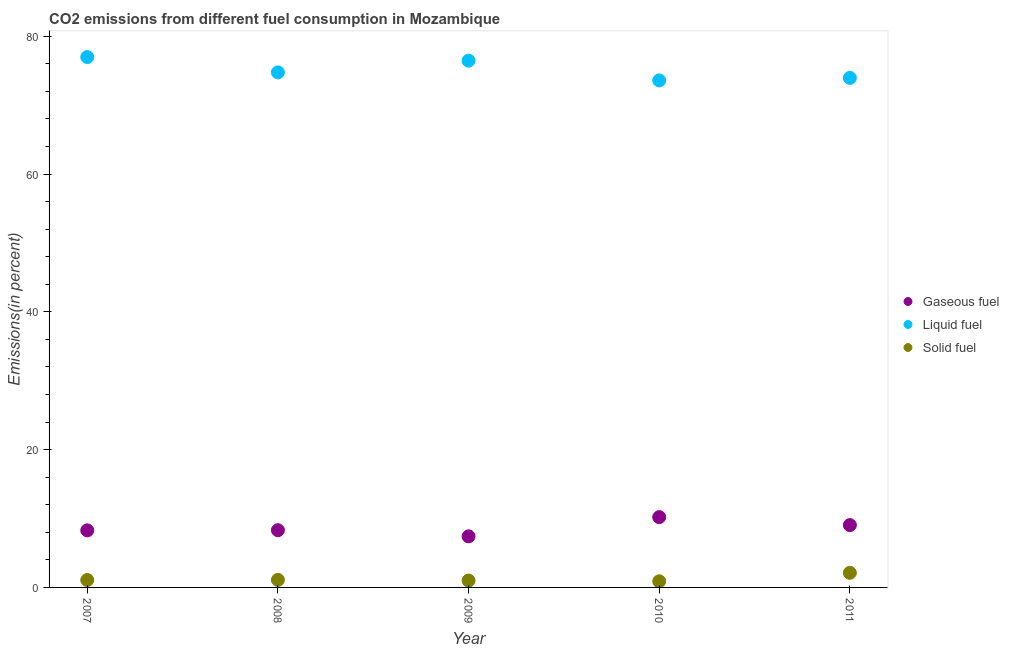What is the percentage of solid fuel emission in 2008?
Provide a short and direct response. 1.1. Across all years, what is the maximum percentage of gaseous fuel emission?
Ensure brevity in your answer.  10.2. Across all years, what is the minimum percentage of gaseous fuel emission?
Your answer should be very brief. 7.42. In which year was the percentage of gaseous fuel emission maximum?
Provide a short and direct response. 2010. What is the total percentage of gaseous fuel emission in the graph?
Provide a short and direct response. 43.26. What is the difference between the percentage of solid fuel emission in 2007 and that in 2011?
Keep it short and to the point. -1.05. What is the difference between the percentage of gaseous fuel emission in 2011 and the percentage of liquid fuel emission in 2009?
Provide a succinct answer. -67.41. What is the average percentage of liquid fuel emission per year?
Make the answer very short. 75.16. In the year 2007, what is the difference between the percentage of liquid fuel emission and percentage of gaseous fuel emission?
Give a very brief answer. 68.71. What is the ratio of the percentage of liquid fuel emission in 2008 to that in 2009?
Keep it short and to the point. 0.98. Is the difference between the percentage of liquid fuel emission in 2008 and 2009 greater than the difference between the percentage of gaseous fuel emission in 2008 and 2009?
Make the answer very short. No. What is the difference between the highest and the second highest percentage of solid fuel emission?
Provide a short and direct response. 1.03. What is the difference between the highest and the lowest percentage of liquid fuel emission?
Offer a terse response. 3.4. Is the sum of the percentage of gaseous fuel emission in 2007 and 2010 greater than the maximum percentage of liquid fuel emission across all years?
Offer a terse response. No. Is it the case that in every year, the sum of the percentage of gaseous fuel emission and percentage of liquid fuel emission is greater than the percentage of solid fuel emission?
Offer a very short reply. Yes. Does the percentage of liquid fuel emission monotonically increase over the years?
Your response must be concise. No. Is the percentage of gaseous fuel emission strictly less than the percentage of solid fuel emission over the years?
Your answer should be compact. No. How many dotlines are there?
Offer a very short reply. 3. How many years are there in the graph?
Your answer should be very brief. 5. Does the graph contain grids?
Provide a succinct answer. No. How are the legend labels stacked?
Your response must be concise. Vertical. What is the title of the graph?
Offer a very short reply. CO2 emissions from different fuel consumption in Mozambique. What is the label or title of the Y-axis?
Make the answer very short. Emissions(in percent). What is the Emissions(in percent) of Gaseous fuel in 2007?
Your answer should be very brief. 8.28. What is the Emissions(in percent) in Liquid fuel in 2007?
Offer a very short reply. 76.99. What is the Emissions(in percent) of Solid fuel in 2007?
Your answer should be compact. 1.07. What is the Emissions(in percent) in Gaseous fuel in 2008?
Make the answer very short. 8.31. What is the Emissions(in percent) of Liquid fuel in 2008?
Give a very brief answer. 74.76. What is the Emissions(in percent) in Solid fuel in 2008?
Offer a very short reply. 1.1. What is the Emissions(in percent) of Gaseous fuel in 2009?
Your response must be concise. 7.42. What is the Emissions(in percent) in Liquid fuel in 2009?
Your answer should be compact. 76.46. What is the Emissions(in percent) in Solid fuel in 2009?
Give a very brief answer. 1. What is the Emissions(in percent) in Gaseous fuel in 2010?
Your answer should be compact. 10.2. What is the Emissions(in percent) in Liquid fuel in 2010?
Offer a very short reply. 73.6. What is the Emissions(in percent) of Solid fuel in 2010?
Your response must be concise. 0.89. What is the Emissions(in percent) in Gaseous fuel in 2011?
Give a very brief answer. 9.05. What is the Emissions(in percent) in Liquid fuel in 2011?
Offer a terse response. 73.97. What is the Emissions(in percent) of Solid fuel in 2011?
Provide a short and direct response. 2.12. Across all years, what is the maximum Emissions(in percent) of Gaseous fuel?
Give a very brief answer. 10.2. Across all years, what is the maximum Emissions(in percent) of Liquid fuel?
Provide a succinct answer. 76.99. Across all years, what is the maximum Emissions(in percent) of Solid fuel?
Provide a succinct answer. 2.12. Across all years, what is the minimum Emissions(in percent) in Gaseous fuel?
Make the answer very short. 7.42. Across all years, what is the minimum Emissions(in percent) of Liquid fuel?
Make the answer very short. 73.6. Across all years, what is the minimum Emissions(in percent) in Solid fuel?
Your response must be concise. 0.89. What is the total Emissions(in percent) in Gaseous fuel in the graph?
Your answer should be very brief. 43.26. What is the total Emissions(in percent) of Liquid fuel in the graph?
Make the answer very short. 375.78. What is the total Emissions(in percent) in Solid fuel in the graph?
Your answer should be very brief. 6.19. What is the difference between the Emissions(in percent) of Gaseous fuel in 2007 and that in 2008?
Your response must be concise. -0.03. What is the difference between the Emissions(in percent) of Liquid fuel in 2007 and that in 2008?
Provide a succinct answer. 2.23. What is the difference between the Emissions(in percent) of Solid fuel in 2007 and that in 2008?
Ensure brevity in your answer.  -0.02. What is the difference between the Emissions(in percent) of Gaseous fuel in 2007 and that in 2009?
Provide a succinct answer. 0.86. What is the difference between the Emissions(in percent) in Liquid fuel in 2007 and that in 2009?
Your answer should be compact. 0.53. What is the difference between the Emissions(in percent) of Solid fuel in 2007 and that in 2009?
Your answer should be compact. 0.07. What is the difference between the Emissions(in percent) in Gaseous fuel in 2007 and that in 2010?
Provide a short and direct response. -1.92. What is the difference between the Emissions(in percent) in Liquid fuel in 2007 and that in 2010?
Ensure brevity in your answer.  3.4. What is the difference between the Emissions(in percent) of Solid fuel in 2007 and that in 2010?
Keep it short and to the point. 0.18. What is the difference between the Emissions(in percent) of Gaseous fuel in 2007 and that in 2011?
Offer a very short reply. -0.77. What is the difference between the Emissions(in percent) of Liquid fuel in 2007 and that in 2011?
Ensure brevity in your answer.  3.03. What is the difference between the Emissions(in percent) of Solid fuel in 2007 and that in 2011?
Give a very brief answer. -1.05. What is the difference between the Emissions(in percent) in Gaseous fuel in 2008 and that in 2009?
Give a very brief answer. 0.89. What is the difference between the Emissions(in percent) in Liquid fuel in 2008 and that in 2009?
Your answer should be very brief. -1.7. What is the difference between the Emissions(in percent) in Solid fuel in 2008 and that in 2009?
Make the answer very short. 0.1. What is the difference between the Emissions(in percent) in Gaseous fuel in 2008 and that in 2010?
Give a very brief answer. -1.9. What is the difference between the Emissions(in percent) of Liquid fuel in 2008 and that in 2010?
Your answer should be very brief. 1.17. What is the difference between the Emissions(in percent) of Solid fuel in 2008 and that in 2010?
Keep it short and to the point. 0.2. What is the difference between the Emissions(in percent) of Gaseous fuel in 2008 and that in 2011?
Provide a short and direct response. -0.74. What is the difference between the Emissions(in percent) in Liquid fuel in 2008 and that in 2011?
Your answer should be compact. 0.8. What is the difference between the Emissions(in percent) of Solid fuel in 2008 and that in 2011?
Your response must be concise. -1.03. What is the difference between the Emissions(in percent) of Gaseous fuel in 2009 and that in 2010?
Offer a terse response. -2.79. What is the difference between the Emissions(in percent) in Liquid fuel in 2009 and that in 2010?
Keep it short and to the point. 2.87. What is the difference between the Emissions(in percent) of Solid fuel in 2009 and that in 2010?
Your answer should be very brief. 0.11. What is the difference between the Emissions(in percent) in Gaseous fuel in 2009 and that in 2011?
Ensure brevity in your answer.  -1.63. What is the difference between the Emissions(in percent) in Liquid fuel in 2009 and that in 2011?
Provide a short and direct response. 2.5. What is the difference between the Emissions(in percent) in Solid fuel in 2009 and that in 2011?
Your answer should be very brief. -1.12. What is the difference between the Emissions(in percent) of Gaseous fuel in 2010 and that in 2011?
Keep it short and to the point. 1.15. What is the difference between the Emissions(in percent) in Liquid fuel in 2010 and that in 2011?
Give a very brief answer. -0.37. What is the difference between the Emissions(in percent) in Solid fuel in 2010 and that in 2011?
Provide a short and direct response. -1.23. What is the difference between the Emissions(in percent) in Gaseous fuel in 2007 and the Emissions(in percent) in Liquid fuel in 2008?
Make the answer very short. -66.48. What is the difference between the Emissions(in percent) of Gaseous fuel in 2007 and the Emissions(in percent) of Solid fuel in 2008?
Provide a short and direct response. 7.18. What is the difference between the Emissions(in percent) in Liquid fuel in 2007 and the Emissions(in percent) in Solid fuel in 2008?
Your answer should be compact. 75.9. What is the difference between the Emissions(in percent) in Gaseous fuel in 2007 and the Emissions(in percent) in Liquid fuel in 2009?
Provide a short and direct response. -68.18. What is the difference between the Emissions(in percent) of Gaseous fuel in 2007 and the Emissions(in percent) of Solid fuel in 2009?
Your answer should be compact. 7.28. What is the difference between the Emissions(in percent) of Liquid fuel in 2007 and the Emissions(in percent) of Solid fuel in 2009?
Give a very brief answer. 76. What is the difference between the Emissions(in percent) in Gaseous fuel in 2007 and the Emissions(in percent) in Liquid fuel in 2010?
Keep it short and to the point. -65.31. What is the difference between the Emissions(in percent) in Gaseous fuel in 2007 and the Emissions(in percent) in Solid fuel in 2010?
Make the answer very short. 7.39. What is the difference between the Emissions(in percent) in Liquid fuel in 2007 and the Emissions(in percent) in Solid fuel in 2010?
Offer a very short reply. 76.1. What is the difference between the Emissions(in percent) in Gaseous fuel in 2007 and the Emissions(in percent) in Liquid fuel in 2011?
Give a very brief answer. -65.68. What is the difference between the Emissions(in percent) of Gaseous fuel in 2007 and the Emissions(in percent) of Solid fuel in 2011?
Give a very brief answer. 6.16. What is the difference between the Emissions(in percent) of Liquid fuel in 2007 and the Emissions(in percent) of Solid fuel in 2011?
Give a very brief answer. 74.87. What is the difference between the Emissions(in percent) of Gaseous fuel in 2008 and the Emissions(in percent) of Liquid fuel in 2009?
Offer a terse response. -68.16. What is the difference between the Emissions(in percent) of Gaseous fuel in 2008 and the Emissions(in percent) of Solid fuel in 2009?
Make the answer very short. 7.31. What is the difference between the Emissions(in percent) of Liquid fuel in 2008 and the Emissions(in percent) of Solid fuel in 2009?
Make the answer very short. 73.77. What is the difference between the Emissions(in percent) of Gaseous fuel in 2008 and the Emissions(in percent) of Liquid fuel in 2010?
Your response must be concise. -65.29. What is the difference between the Emissions(in percent) in Gaseous fuel in 2008 and the Emissions(in percent) in Solid fuel in 2010?
Provide a succinct answer. 7.41. What is the difference between the Emissions(in percent) of Liquid fuel in 2008 and the Emissions(in percent) of Solid fuel in 2010?
Offer a terse response. 73.87. What is the difference between the Emissions(in percent) of Gaseous fuel in 2008 and the Emissions(in percent) of Liquid fuel in 2011?
Keep it short and to the point. -65.66. What is the difference between the Emissions(in percent) of Gaseous fuel in 2008 and the Emissions(in percent) of Solid fuel in 2011?
Ensure brevity in your answer.  6.18. What is the difference between the Emissions(in percent) in Liquid fuel in 2008 and the Emissions(in percent) in Solid fuel in 2011?
Your response must be concise. 72.64. What is the difference between the Emissions(in percent) in Gaseous fuel in 2009 and the Emissions(in percent) in Liquid fuel in 2010?
Offer a very short reply. -66.18. What is the difference between the Emissions(in percent) of Gaseous fuel in 2009 and the Emissions(in percent) of Solid fuel in 2010?
Make the answer very short. 6.53. What is the difference between the Emissions(in percent) of Liquid fuel in 2009 and the Emissions(in percent) of Solid fuel in 2010?
Offer a very short reply. 75.57. What is the difference between the Emissions(in percent) of Gaseous fuel in 2009 and the Emissions(in percent) of Liquid fuel in 2011?
Make the answer very short. -66.55. What is the difference between the Emissions(in percent) of Gaseous fuel in 2009 and the Emissions(in percent) of Solid fuel in 2011?
Ensure brevity in your answer.  5.3. What is the difference between the Emissions(in percent) of Liquid fuel in 2009 and the Emissions(in percent) of Solid fuel in 2011?
Your answer should be very brief. 74.34. What is the difference between the Emissions(in percent) in Gaseous fuel in 2010 and the Emissions(in percent) in Liquid fuel in 2011?
Give a very brief answer. -63.76. What is the difference between the Emissions(in percent) of Gaseous fuel in 2010 and the Emissions(in percent) of Solid fuel in 2011?
Your answer should be compact. 8.08. What is the difference between the Emissions(in percent) in Liquid fuel in 2010 and the Emissions(in percent) in Solid fuel in 2011?
Offer a very short reply. 71.47. What is the average Emissions(in percent) in Gaseous fuel per year?
Your answer should be compact. 8.65. What is the average Emissions(in percent) in Liquid fuel per year?
Provide a succinct answer. 75.16. What is the average Emissions(in percent) of Solid fuel per year?
Provide a short and direct response. 1.24. In the year 2007, what is the difference between the Emissions(in percent) of Gaseous fuel and Emissions(in percent) of Liquid fuel?
Keep it short and to the point. -68.71. In the year 2007, what is the difference between the Emissions(in percent) in Gaseous fuel and Emissions(in percent) in Solid fuel?
Offer a terse response. 7.21. In the year 2007, what is the difference between the Emissions(in percent) in Liquid fuel and Emissions(in percent) in Solid fuel?
Offer a very short reply. 75.92. In the year 2008, what is the difference between the Emissions(in percent) in Gaseous fuel and Emissions(in percent) in Liquid fuel?
Ensure brevity in your answer.  -66.46. In the year 2008, what is the difference between the Emissions(in percent) in Gaseous fuel and Emissions(in percent) in Solid fuel?
Give a very brief answer. 7.21. In the year 2008, what is the difference between the Emissions(in percent) of Liquid fuel and Emissions(in percent) of Solid fuel?
Your answer should be compact. 73.67. In the year 2009, what is the difference between the Emissions(in percent) of Gaseous fuel and Emissions(in percent) of Liquid fuel?
Offer a very short reply. -69.04. In the year 2009, what is the difference between the Emissions(in percent) of Gaseous fuel and Emissions(in percent) of Solid fuel?
Offer a terse response. 6.42. In the year 2009, what is the difference between the Emissions(in percent) in Liquid fuel and Emissions(in percent) in Solid fuel?
Offer a terse response. 75.46. In the year 2010, what is the difference between the Emissions(in percent) in Gaseous fuel and Emissions(in percent) in Liquid fuel?
Keep it short and to the point. -63.39. In the year 2010, what is the difference between the Emissions(in percent) of Gaseous fuel and Emissions(in percent) of Solid fuel?
Provide a succinct answer. 9.31. In the year 2010, what is the difference between the Emissions(in percent) in Liquid fuel and Emissions(in percent) in Solid fuel?
Provide a short and direct response. 72.7. In the year 2011, what is the difference between the Emissions(in percent) of Gaseous fuel and Emissions(in percent) of Liquid fuel?
Your answer should be very brief. -64.92. In the year 2011, what is the difference between the Emissions(in percent) of Gaseous fuel and Emissions(in percent) of Solid fuel?
Provide a short and direct response. 6.93. In the year 2011, what is the difference between the Emissions(in percent) of Liquid fuel and Emissions(in percent) of Solid fuel?
Your answer should be very brief. 71.84. What is the ratio of the Emissions(in percent) in Liquid fuel in 2007 to that in 2008?
Provide a succinct answer. 1.03. What is the ratio of the Emissions(in percent) of Solid fuel in 2007 to that in 2008?
Make the answer very short. 0.98. What is the ratio of the Emissions(in percent) of Gaseous fuel in 2007 to that in 2009?
Your answer should be very brief. 1.12. What is the ratio of the Emissions(in percent) in Solid fuel in 2007 to that in 2009?
Keep it short and to the point. 1.08. What is the ratio of the Emissions(in percent) in Gaseous fuel in 2007 to that in 2010?
Provide a succinct answer. 0.81. What is the ratio of the Emissions(in percent) of Liquid fuel in 2007 to that in 2010?
Your answer should be very brief. 1.05. What is the ratio of the Emissions(in percent) in Solid fuel in 2007 to that in 2010?
Provide a short and direct response. 1.2. What is the ratio of the Emissions(in percent) in Gaseous fuel in 2007 to that in 2011?
Your response must be concise. 0.92. What is the ratio of the Emissions(in percent) of Liquid fuel in 2007 to that in 2011?
Give a very brief answer. 1.04. What is the ratio of the Emissions(in percent) in Solid fuel in 2007 to that in 2011?
Your answer should be compact. 0.51. What is the ratio of the Emissions(in percent) of Gaseous fuel in 2008 to that in 2009?
Provide a succinct answer. 1.12. What is the ratio of the Emissions(in percent) in Liquid fuel in 2008 to that in 2009?
Give a very brief answer. 0.98. What is the ratio of the Emissions(in percent) in Solid fuel in 2008 to that in 2009?
Your response must be concise. 1.1. What is the ratio of the Emissions(in percent) in Gaseous fuel in 2008 to that in 2010?
Give a very brief answer. 0.81. What is the ratio of the Emissions(in percent) in Liquid fuel in 2008 to that in 2010?
Provide a short and direct response. 1.02. What is the ratio of the Emissions(in percent) in Solid fuel in 2008 to that in 2010?
Provide a short and direct response. 1.23. What is the ratio of the Emissions(in percent) in Gaseous fuel in 2008 to that in 2011?
Give a very brief answer. 0.92. What is the ratio of the Emissions(in percent) of Liquid fuel in 2008 to that in 2011?
Your answer should be very brief. 1.01. What is the ratio of the Emissions(in percent) of Solid fuel in 2008 to that in 2011?
Your answer should be very brief. 0.52. What is the ratio of the Emissions(in percent) in Gaseous fuel in 2009 to that in 2010?
Provide a succinct answer. 0.73. What is the ratio of the Emissions(in percent) of Liquid fuel in 2009 to that in 2010?
Give a very brief answer. 1.04. What is the ratio of the Emissions(in percent) of Solid fuel in 2009 to that in 2010?
Give a very brief answer. 1.12. What is the ratio of the Emissions(in percent) of Gaseous fuel in 2009 to that in 2011?
Offer a terse response. 0.82. What is the ratio of the Emissions(in percent) of Liquid fuel in 2009 to that in 2011?
Provide a succinct answer. 1.03. What is the ratio of the Emissions(in percent) in Solid fuel in 2009 to that in 2011?
Your response must be concise. 0.47. What is the ratio of the Emissions(in percent) in Gaseous fuel in 2010 to that in 2011?
Provide a short and direct response. 1.13. What is the ratio of the Emissions(in percent) in Solid fuel in 2010 to that in 2011?
Offer a very short reply. 0.42. What is the difference between the highest and the second highest Emissions(in percent) of Gaseous fuel?
Your response must be concise. 1.15. What is the difference between the highest and the second highest Emissions(in percent) of Liquid fuel?
Offer a terse response. 0.53. What is the difference between the highest and the second highest Emissions(in percent) in Solid fuel?
Offer a terse response. 1.03. What is the difference between the highest and the lowest Emissions(in percent) in Gaseous fuel?
Offer a terse response. 2.79. What is the difference between the highest and the lowest Emissions(in percent) of Liquid fuel?
Give a very brief answer. 3.4. What is the difference between the highest and the lowest Emissions(in percent) of Solid fuel?
Your answer should be very brief. 1.23. 